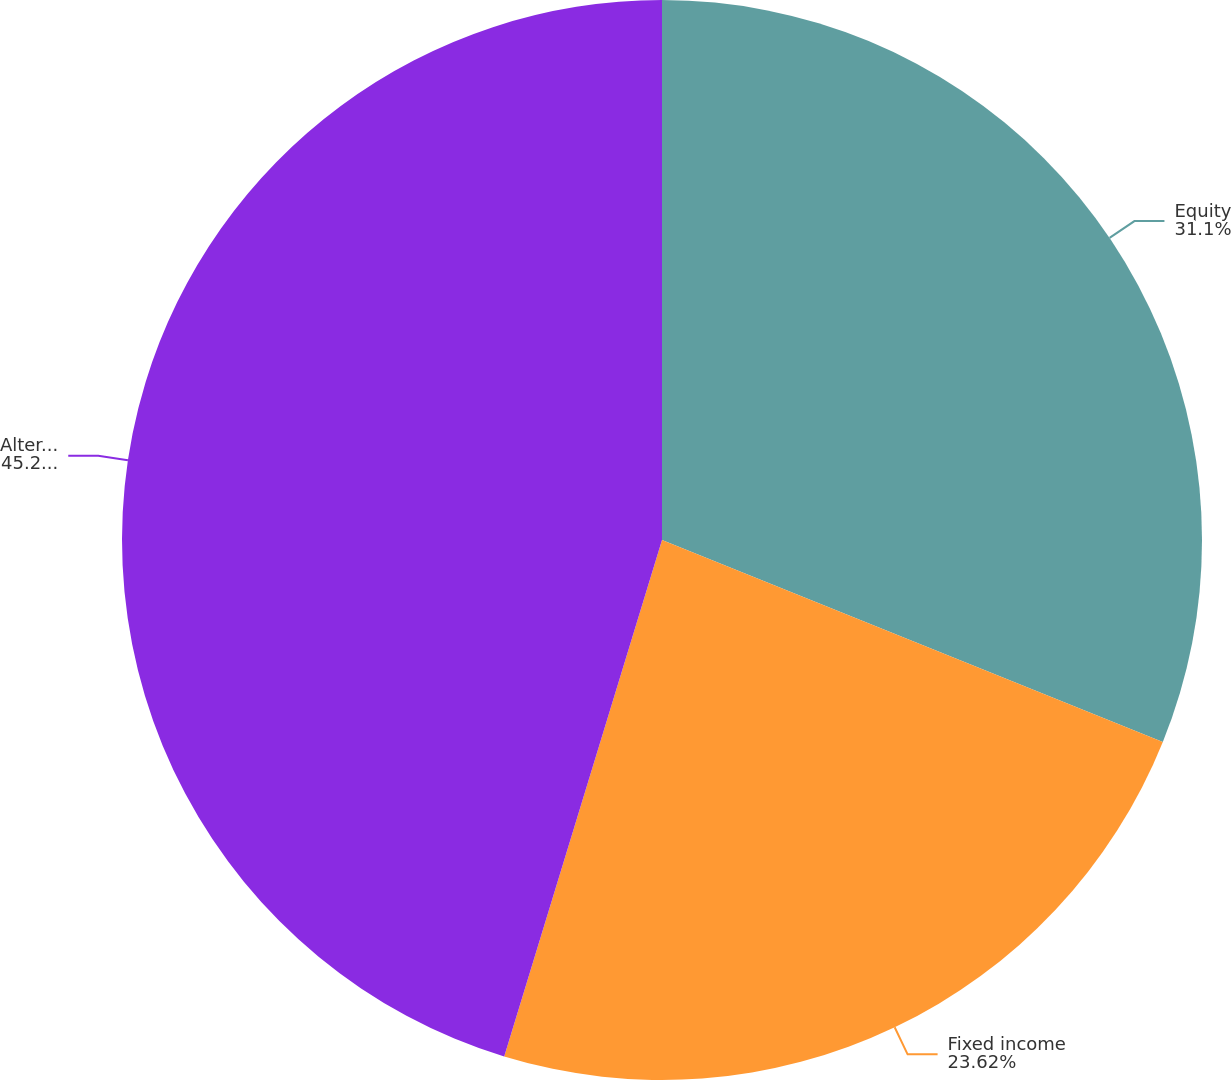Convert chart to OTSL. <chart><loc_0><loc_0><loc_500><loc_500><pie_chart><fcel>Equity<fcel>Fixed income<fcel>Alternative/Other<nl><fcel>31.1%<fcel>23.62%<fcel>45.28%<nl></chart> 